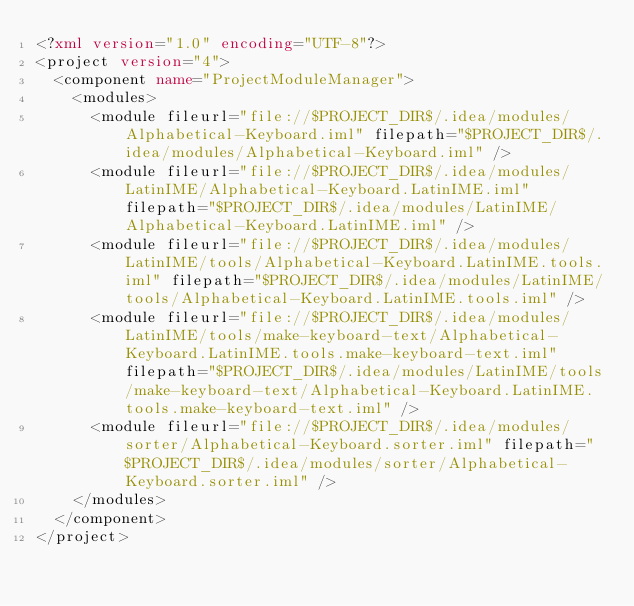Convert code to text. <code><loc_0><loc_0><loc_500><loc_500><_XML_><?xml version="1.0" encoding="UTF-8"?>
<project version="4">
  <component name="ProjectModuleManager">
    <modules>
      <module fileurl="file://$PROJECT_DIR$/.idea/modules/Alphabetical-Keyboard.iml" filepath="$PROJECT_DIR$/.idea/modules/Alphabetical-Keyboard.iml" />
      <module fileurl="file://$PROJECT_DIR$/.idea/modules/LatinIME/Alphabetical-Keyboard.LatinIME.iml" filepath="$PROJECT_DIR$/.idea/modules/LatinIME/Alphabetical-Keyboard.LatinIME.iml" />
      <module fileurl="file://$PROJECT_DIR$/.idea/modules/LatinIME/tools/Alphabetical-Keyboard.LatinIME.tools.iml" filepath="$PROJECT_DIR$/.idea/modules/LatinIME/tools/Alphabetical-Keyboard.LatinIME.tools.iml" />
      <module fileurl="file://$PROJECT_DIR$/.idea/modules/LatinIME/tools/make-keyboard-text/Alphabetical-Keyboard.LatinIME.tools.make-keyboard-text.iml" filepath="$PROJECT_DIR$/.idea/modules/LatinIME/tools/make-keyboard-text/Alphabetical-Keyboard.LatinIME.tools.make-keyboard-text.iml" />
      <module fileurl="file://$PROJECT_DIR$/.idea/modules/sorter/Alphabetical-Keyboard.sorter.iml" filepath="$PROJECT_DIR$/.idea/modules/sorter/Alphabetical-Keyboard.sorter.iml" />
    </modules>
  </component>
</project></code> 